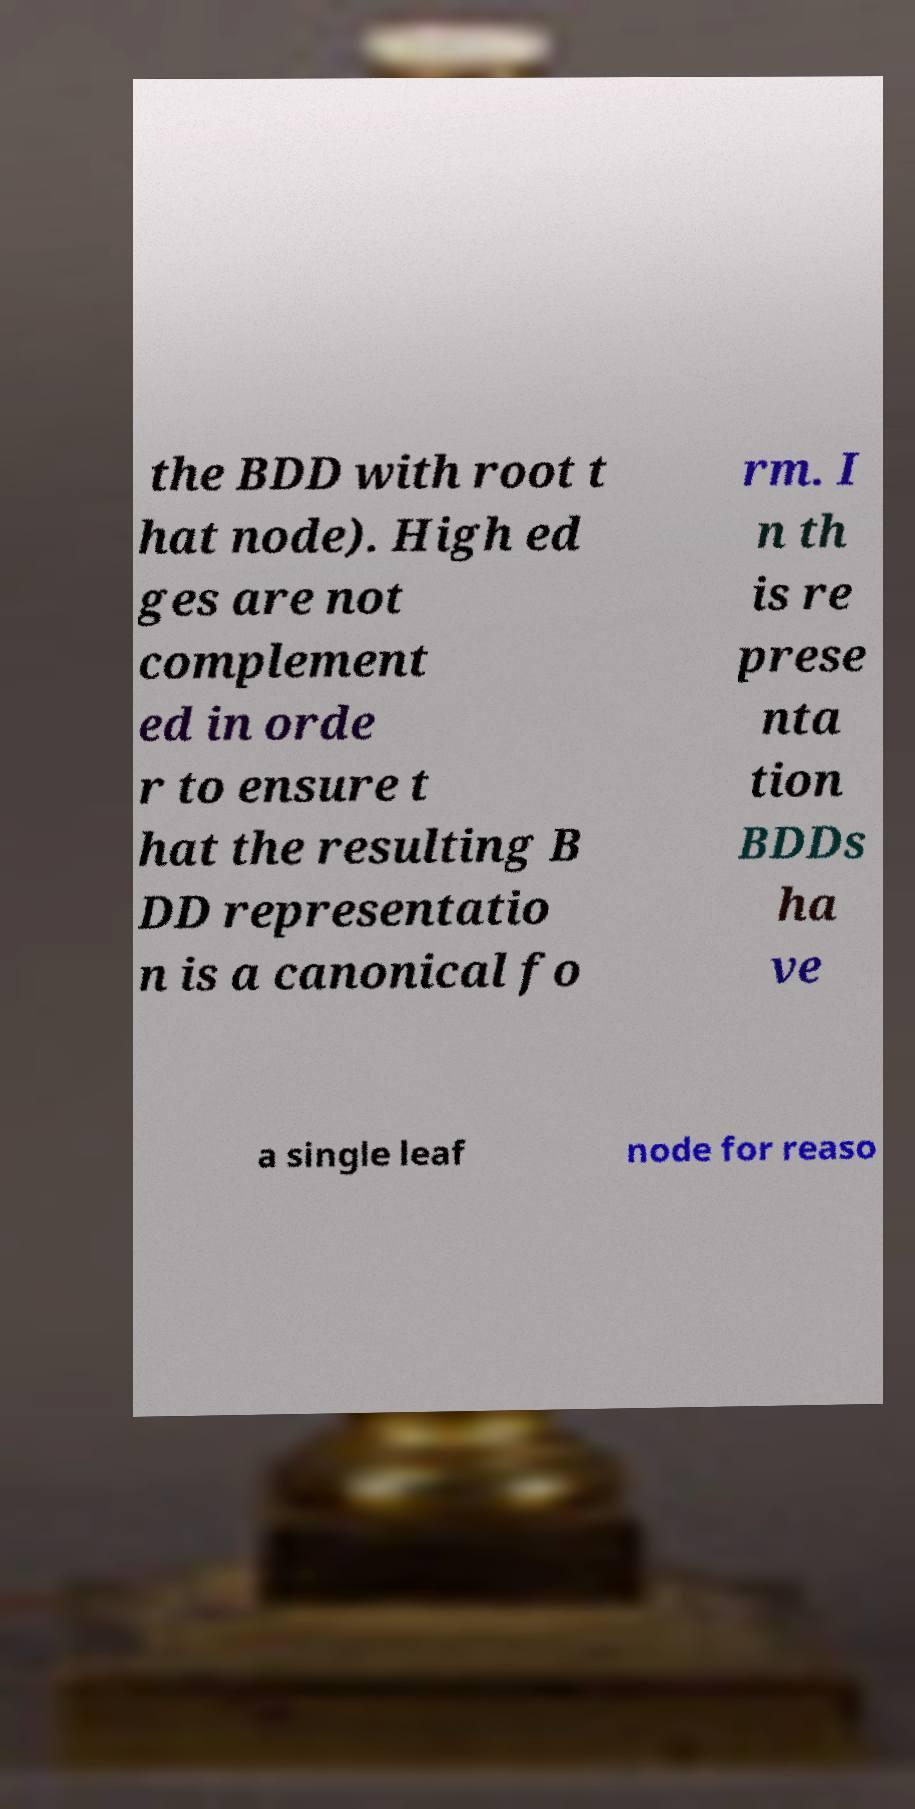Please read and relay the text visible in this image. What does it say? the BDD with root t hat node). High ed ges are not complement ed in orde r to ensure t hat the resulting B DD representatio n is a canonical fo rm. I n th is re prese nta tion BDDs ha ve a single leaf node for reaso 